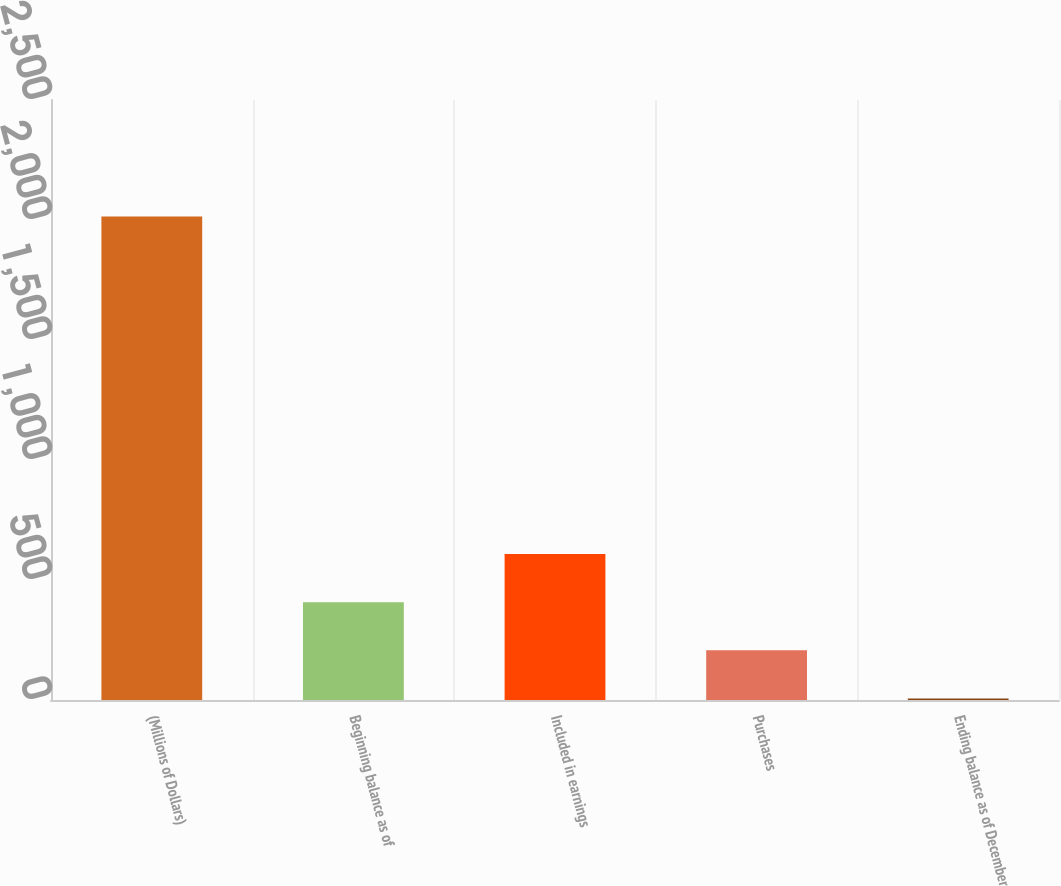Convert chart. <chart><loc_0><loc_0><loc_500><loc_500><bar_chart><fcel>(Millions of Dollars)<fcel>Beginning balance as of<fcel>Included in earnings<fcel>Purchases<fcel>Ending balance as of December<nl><fcel>2015<fcel>407.8<fcel>608.7<fcel>206.9<fcel>6<nl></chart> 